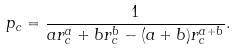Convert formula to latex. <formula><loc_0><loc_0><loc_500><loc_500>p _ { c } = \frac { 1 } { a r _ { c } ^ { a } + b r _ { c } ^ { b } - ( a + b ) r _ { c } ^ { a + b } } .</formula> 